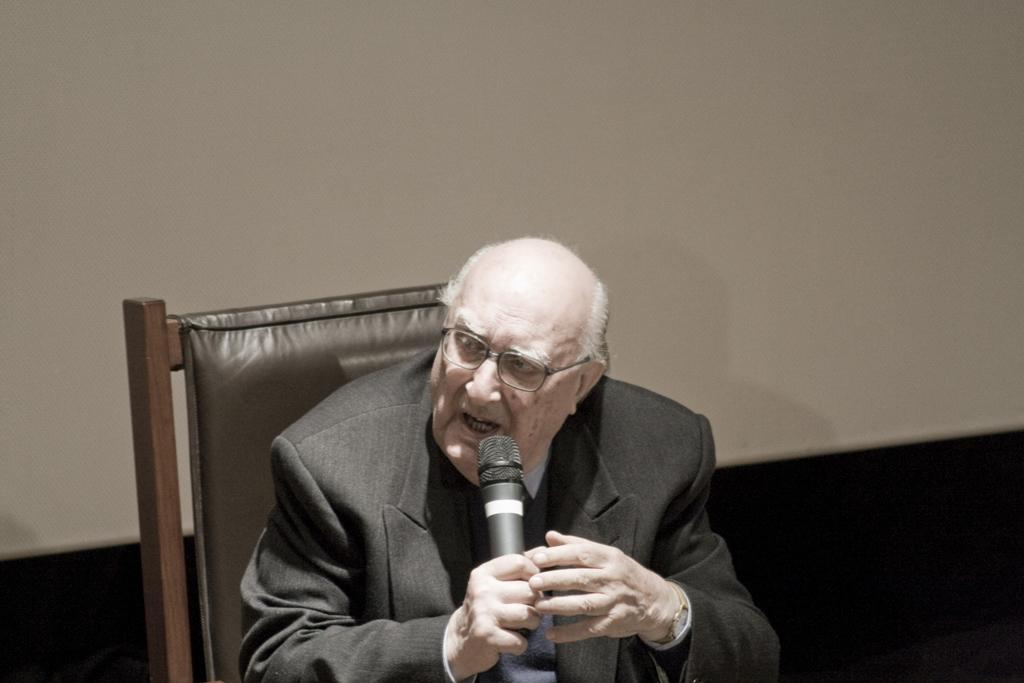Who or what is the main subject in the image? There is a person in the image. What is the person doing in the image? The person is sitting on a chair and holding a mic. What can be seen in the background of the image? There is a wall in the background of the image. What type of current can be seen flowing through the sea in the image? There is no sea or current present in the image; it features a person sitting on a chair and holding a mic with a wall in the background. 